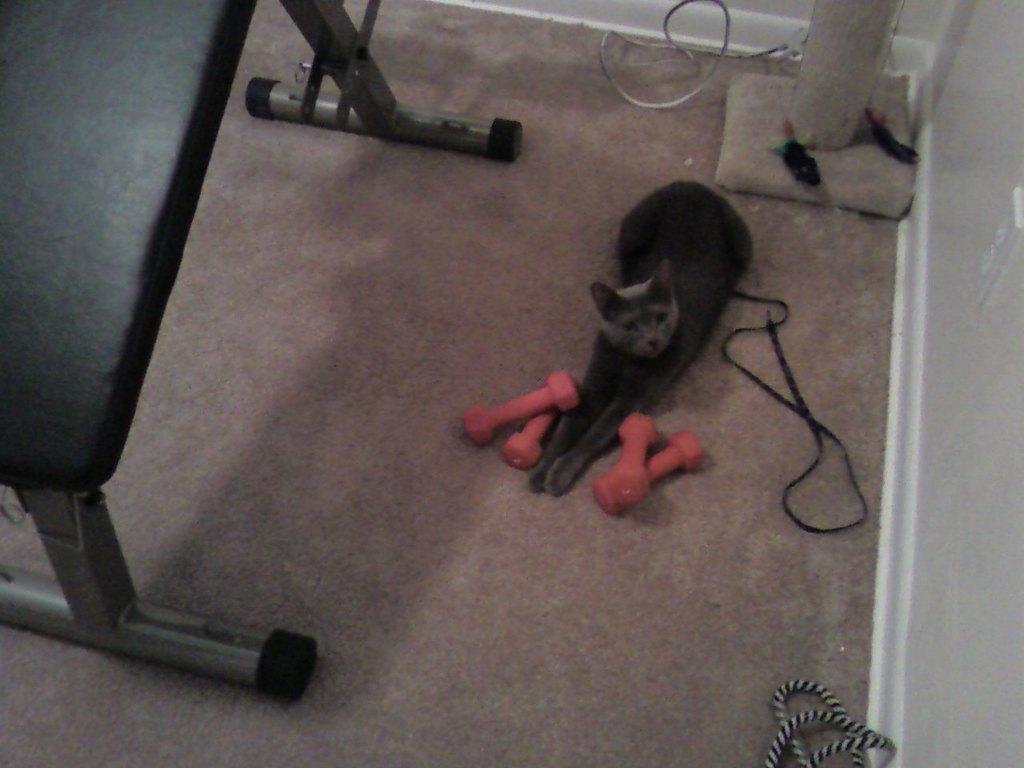Describe this image in one or two sentences. In this image I can see a cat which is back in color on the floor. I can see few pink colored objects on both sides of the cat. I can see few wires, the wall, a pole and a black and silver colored object on the floor. 